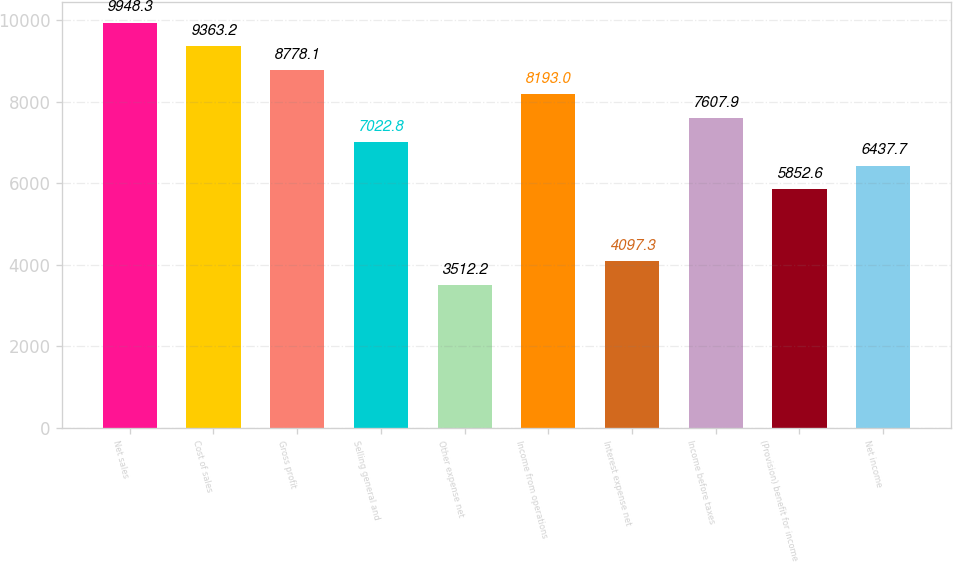Convert chart. <chart><loc_0><loc_0><loc_500><loc_500><bar_chart><fcel>Net sales<fcel>Cost of sales<fcel>Gross profit<fcel>Selling general and<fcel>Other expense net<fcel>Income from operations<fcel>Interest expense net<fcel>Income before taxes<fcel>(Provision) benefit for income<fcel>Net income<nl><fcel>9948.3<fcel>9363.2<fcel>8778.1<fcel>7022.8<fcel>3512.2<fcel>8193<fcel>4097.3<fcel>7607.9<fcel>5852.6<fcel>6437.7<nl></chart> 